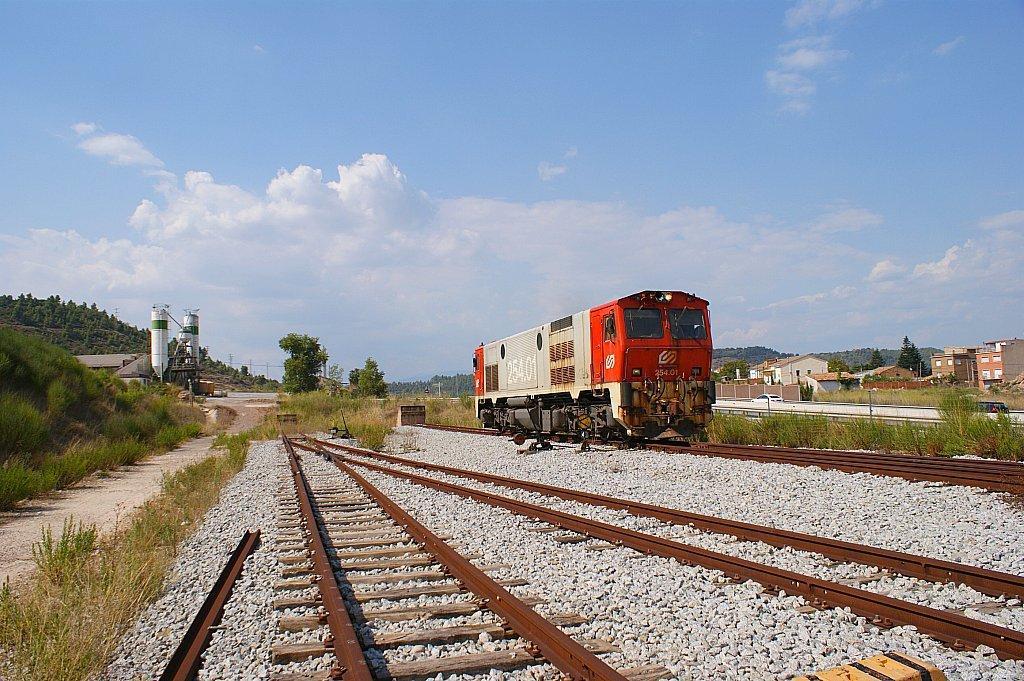Describe this image in one or two sentences. In this image we can see a train is moving on the railway track. Here we can see stones, grass, trees, wooden houses and sky with clouds in the background. 